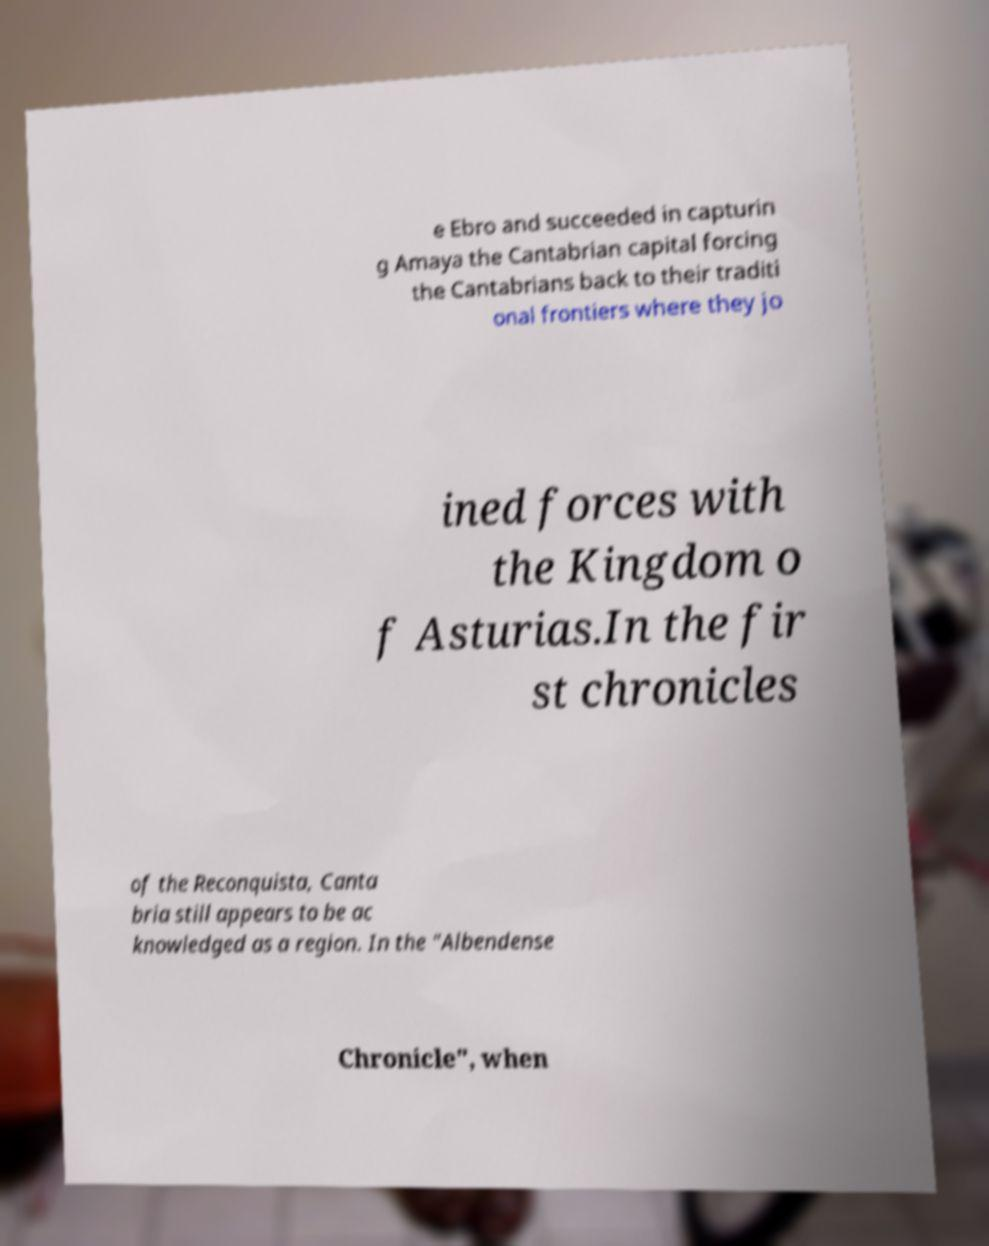Please read and relay the text visible in this image. What does it say? e Ebro and succeeded in capturin g Amaya the Cantabrian capital forcing the Cantabrians back to their traditi onal frontiers where they jo ined forces with the Kingdom o f Asturias.In the fir st chronicles of the Reconquista, Canta bria still appears to be ac knowledged as a region. In the "Albendense Chronicle", when 